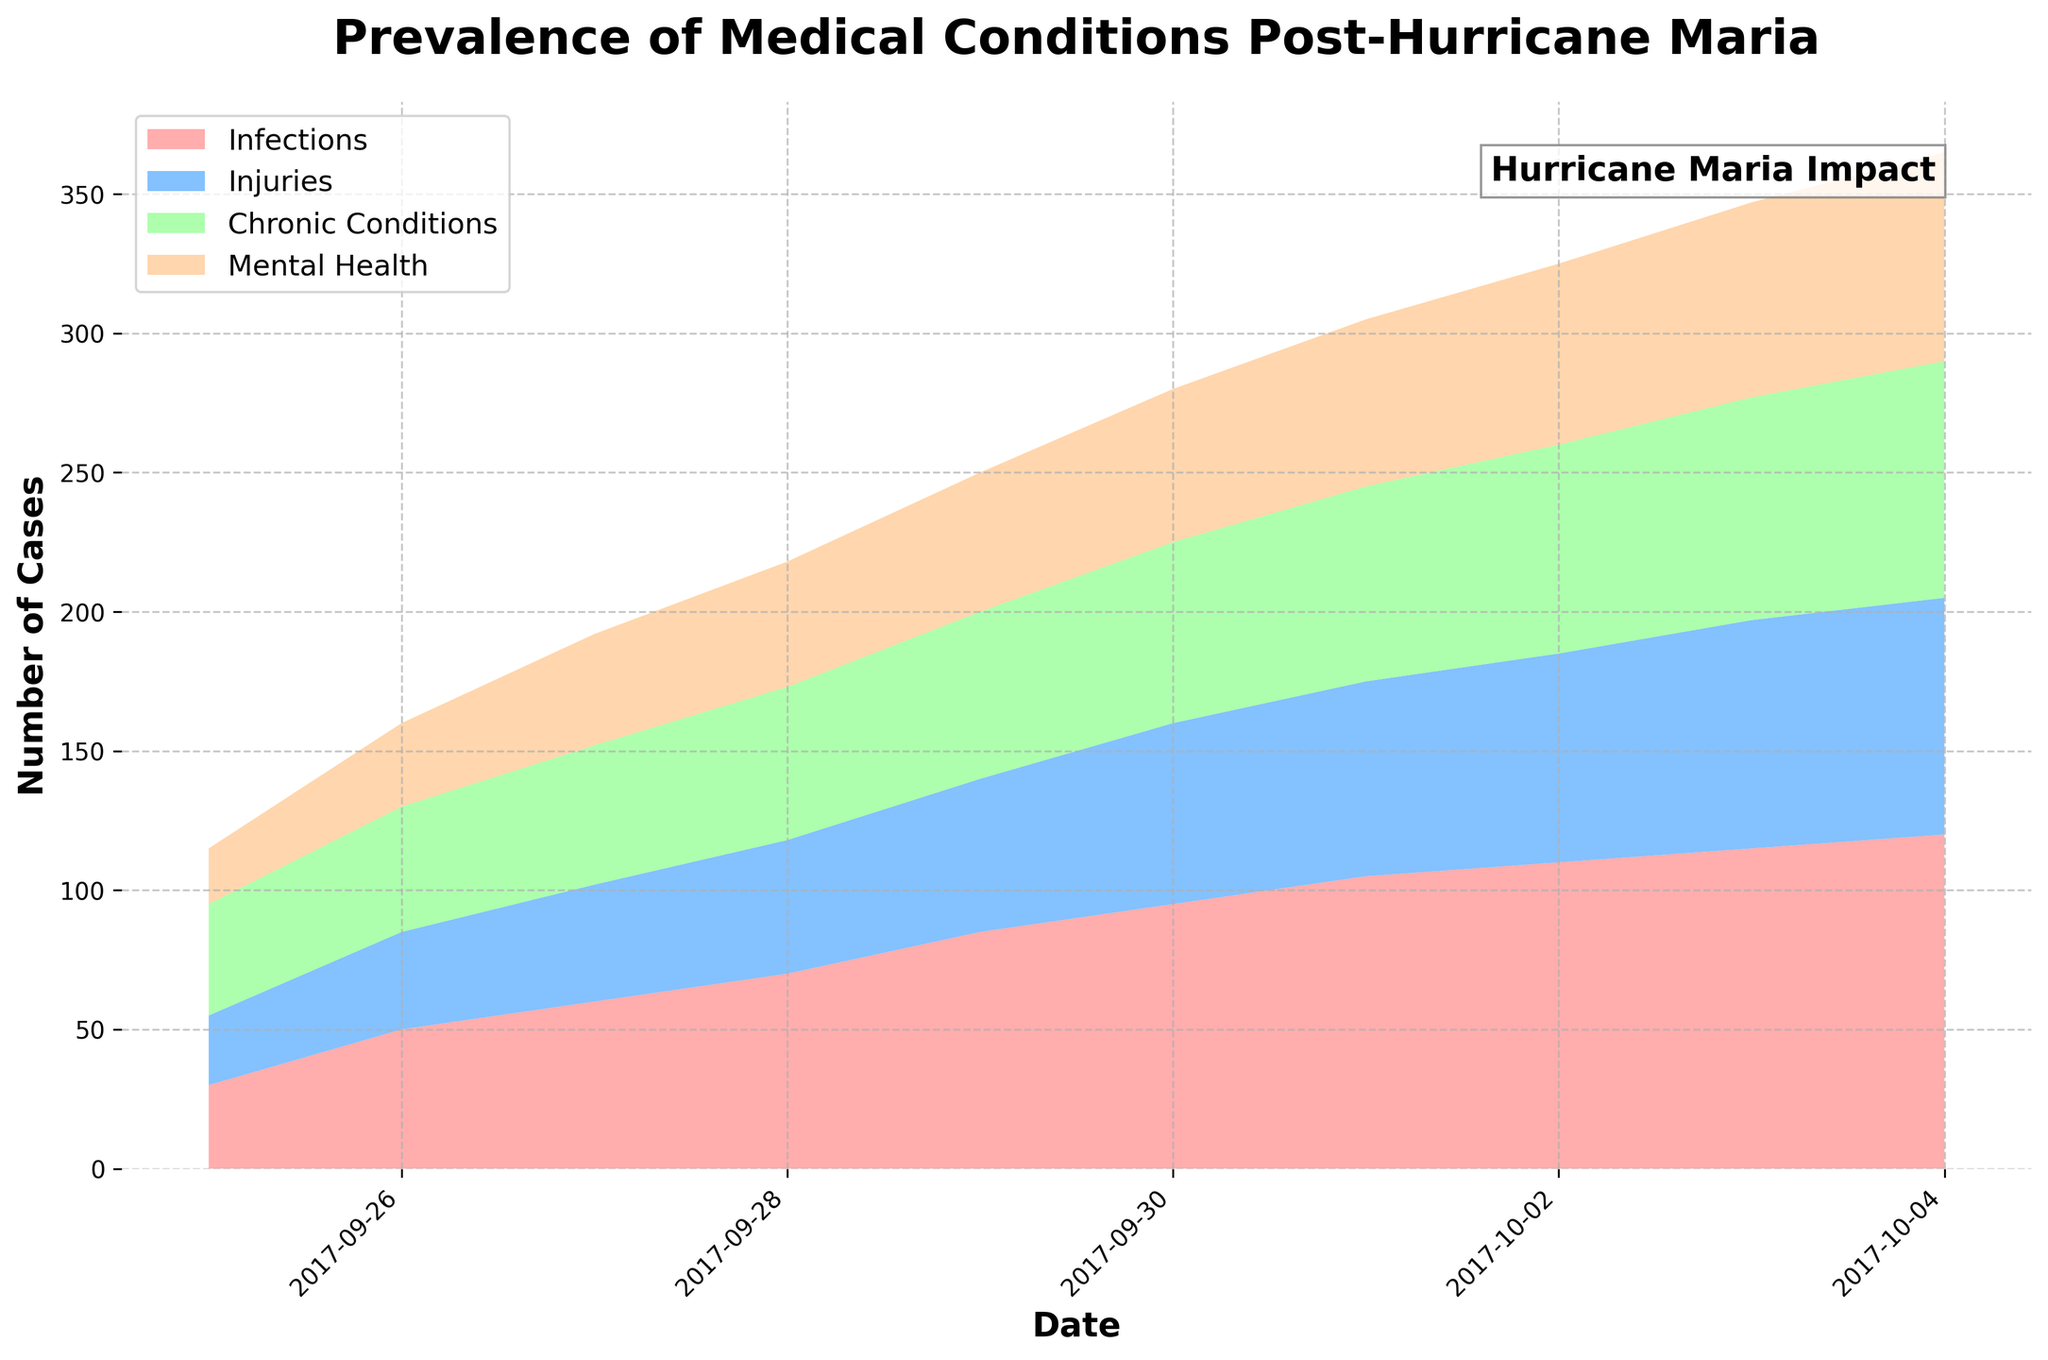What is the title of the plot? The title is given at the top of the figure. It states in large, bold fonts the main subject of the plot.
Answer: Prevalence of Medical Conditions Post-Hurricane Maria Which color represents 'Infections'? The stacked area chart uses different colors for each category, with a corresponding label in the legend.
Answer: Light red How many categories of medical conditions are displayed in the plot? By counting the unique labels present in the legend, you can identify the number of categories.
Answer: Four On which date do 'Mental Health Issues' reach 75 cases? Look for the peak in the 'Mental Health Issues' area along the x-axis that corresponds to the date when the value reaches 75.
Answer: 2017-10-04 What is the trend of 'Injuries' from September 25, 2017, to October 4, 2017? Follow the blue area in the chart from left to right to understand how the number of injury cases changes over time. Formulate a short description of the overall trend.
Answer: It increases What is the sum of 'Chronic Conditions Exacerbation' cases on September 29 and October 1? Check the values on the respective dates for the green area and add them up.
Answer: 60 + 70 = 130 Which category sees the largest increase from September 25 to October 4? Compare the developed areas of each category from the start to the end date to determine which has the most significant change.
Answer: Infections How do cases of 'Mental Health Issues' compare to 'Injuries' on October 2, 2017? Locate both categories on the exact date and compare their values.
Answer: Mental Health Issues (65) > Injuries (75) What is the total number of 'Infections' cases on September 30, 2017? Find the value of the 'Infections' category on September 30th by observing the area plot.
Answer: 95 How does the data distribution look across all categories post-Hurricane Maria? By looking at the entire area chart, describe the proportional distribution and any visible trends in the data for the date range displayed.
Answer: There is a gradual increase in all categories, with 'Infections' having the steepest rise 